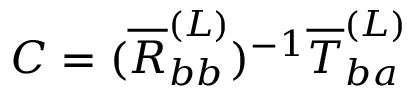Convert formula to latex. <formula><loc_0><loc_0><loc_500><loc_500>C = ( \overline { R } _ { b b } ^ { ( L ) } ) ^ { - 1 } \overline { T } _ { b a } ^ { ( L ) }</formula> 